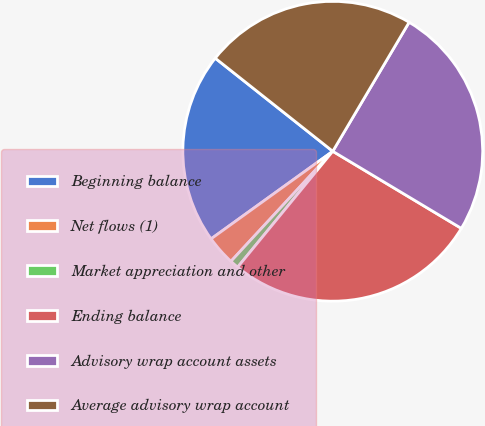<chart> <loc_0><loc_0><loc_500><loc_500><pie_chart><fcel>Beginning balance<fcel>Net flows (1)<fcel>Market appreciation and other<fcel>Ending balance<fcel>Advisory wrap account assets<fcel>Average advisory wrap account<nl><fcel>20.59%<fcel>3.19%<fcel>0.94%<fcel>27.34%<fcel>25.09%<fcel>22.84%<nl></chart> 